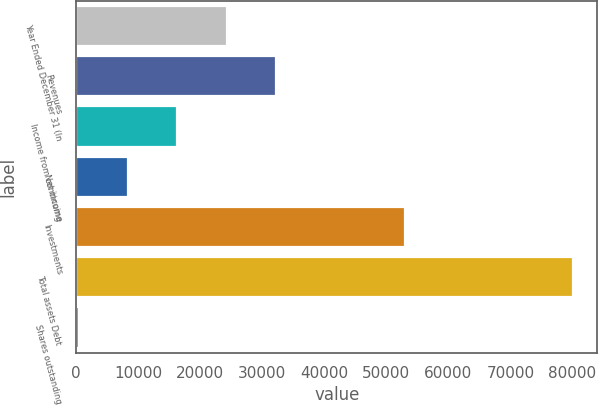<chart> <loc_0><loc_0><loc_500><loc_500><bar_chart><fcel>Year Ended December 31 (In<fcel>Revenues<fcel>Income from continuing<fcel>Net income<fcel>Investments<fcel>Total assets Debt<fcel>Shares outstanding<nl><fcel>24280.6<fcel>32243.5<fcel>16317.6<fcel>8354.73<fcel>53040<fcel>80021<fcel>391.81<nl></chart> 